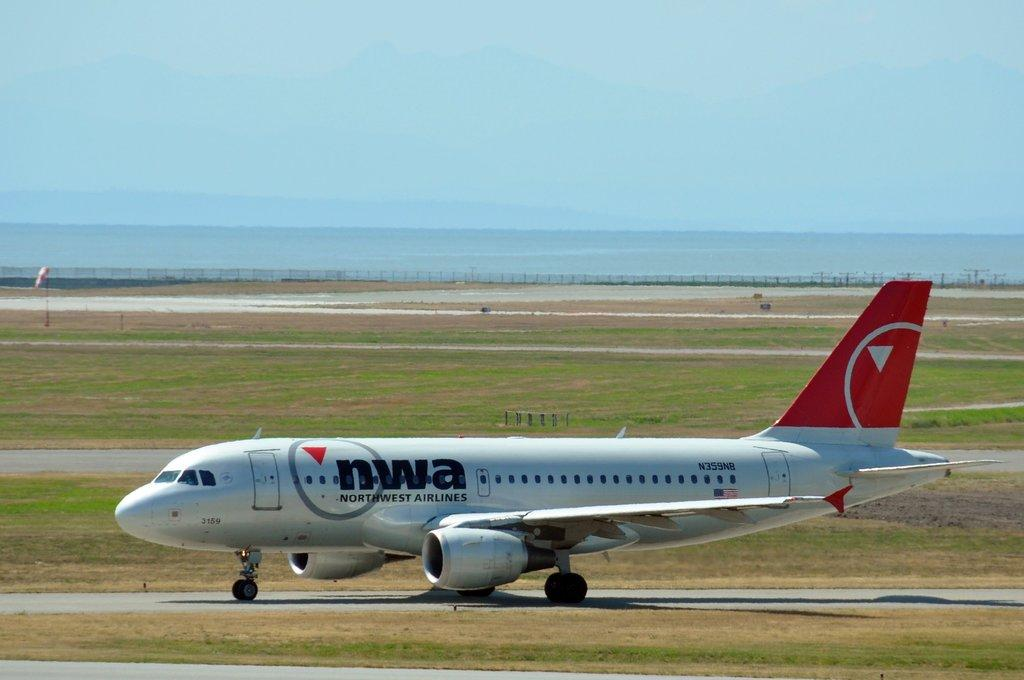What type of vegetation is present in the image? There is grass in the image. What is the main subject in the image? There is a plane in the image. What can be seen in the background of the image? There is a fence in the background of the image. What is visible at the top of the image? The sky is visible at the top of the image. Where is the market located in the image? There is no market present in the image. What type of structure is visible in the image? The image does not show any specific structures; it features grass, a plane, a fence, and the sky. 